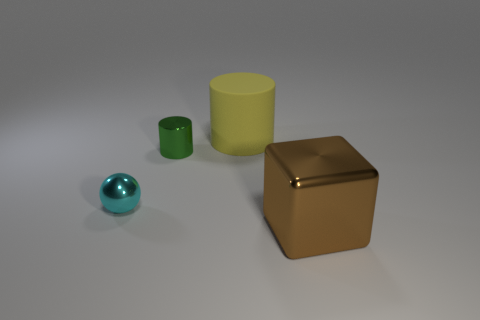Subtract all green cylinders. Subtract all cyan balls. How many cylinders are left? 1 Add 2 balls. How many objects exist? 6 Subtract all cubes. How many objects are left? 3 Add 4 yellow rubber objects. How many yellow rubber objects exist? 5 Subtract 0 brown balls. How many objects are left? 4 Subtract all metal cubes. Subtract all big cubes. How many objects are left? 2 Add 4 shiny spheres. How many shiny spheres are left? 5 